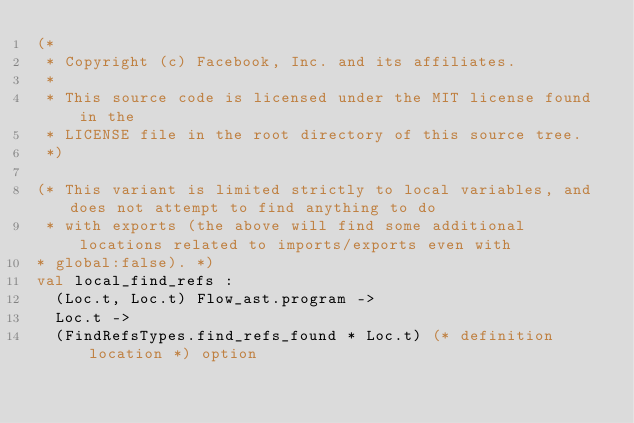<code> <loc_0><loc_0><loc_500><loc_500><_OCaml_>(*
 * Copyright (c) Facebook, Inc. and its affiliates.
 *
 * This source code is licensed under the MIT license found in the
 * LICENSE file in the root directory of this source tree.
 *)

(* This variant is limited strictly to local variables, and does not attempt to find anything to do
 * with exports (the above will find some additional locations related to imports/exports even with
* global:false). *)
val local_find_refs :
  (Loc.t, Loc.t) Flow_ast.program ->
  Loc.t ->
  (FindRefsTypes.find_refs_found * Loc.t) (* definition location *) option
</code> 